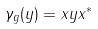Convert formula to latex. <formula><loc_0><loc_0><loc_500><loc_500>\gamma _ { g } ( y ) = x y x ^ { * }</formula> 